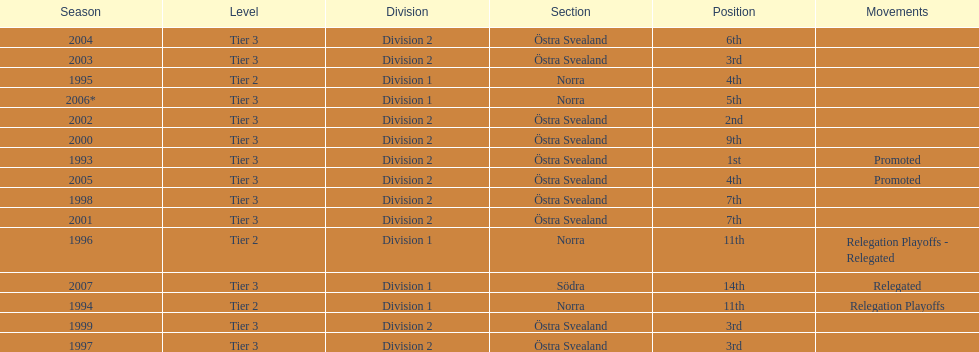What is the only year with the 1st position? 1993. 